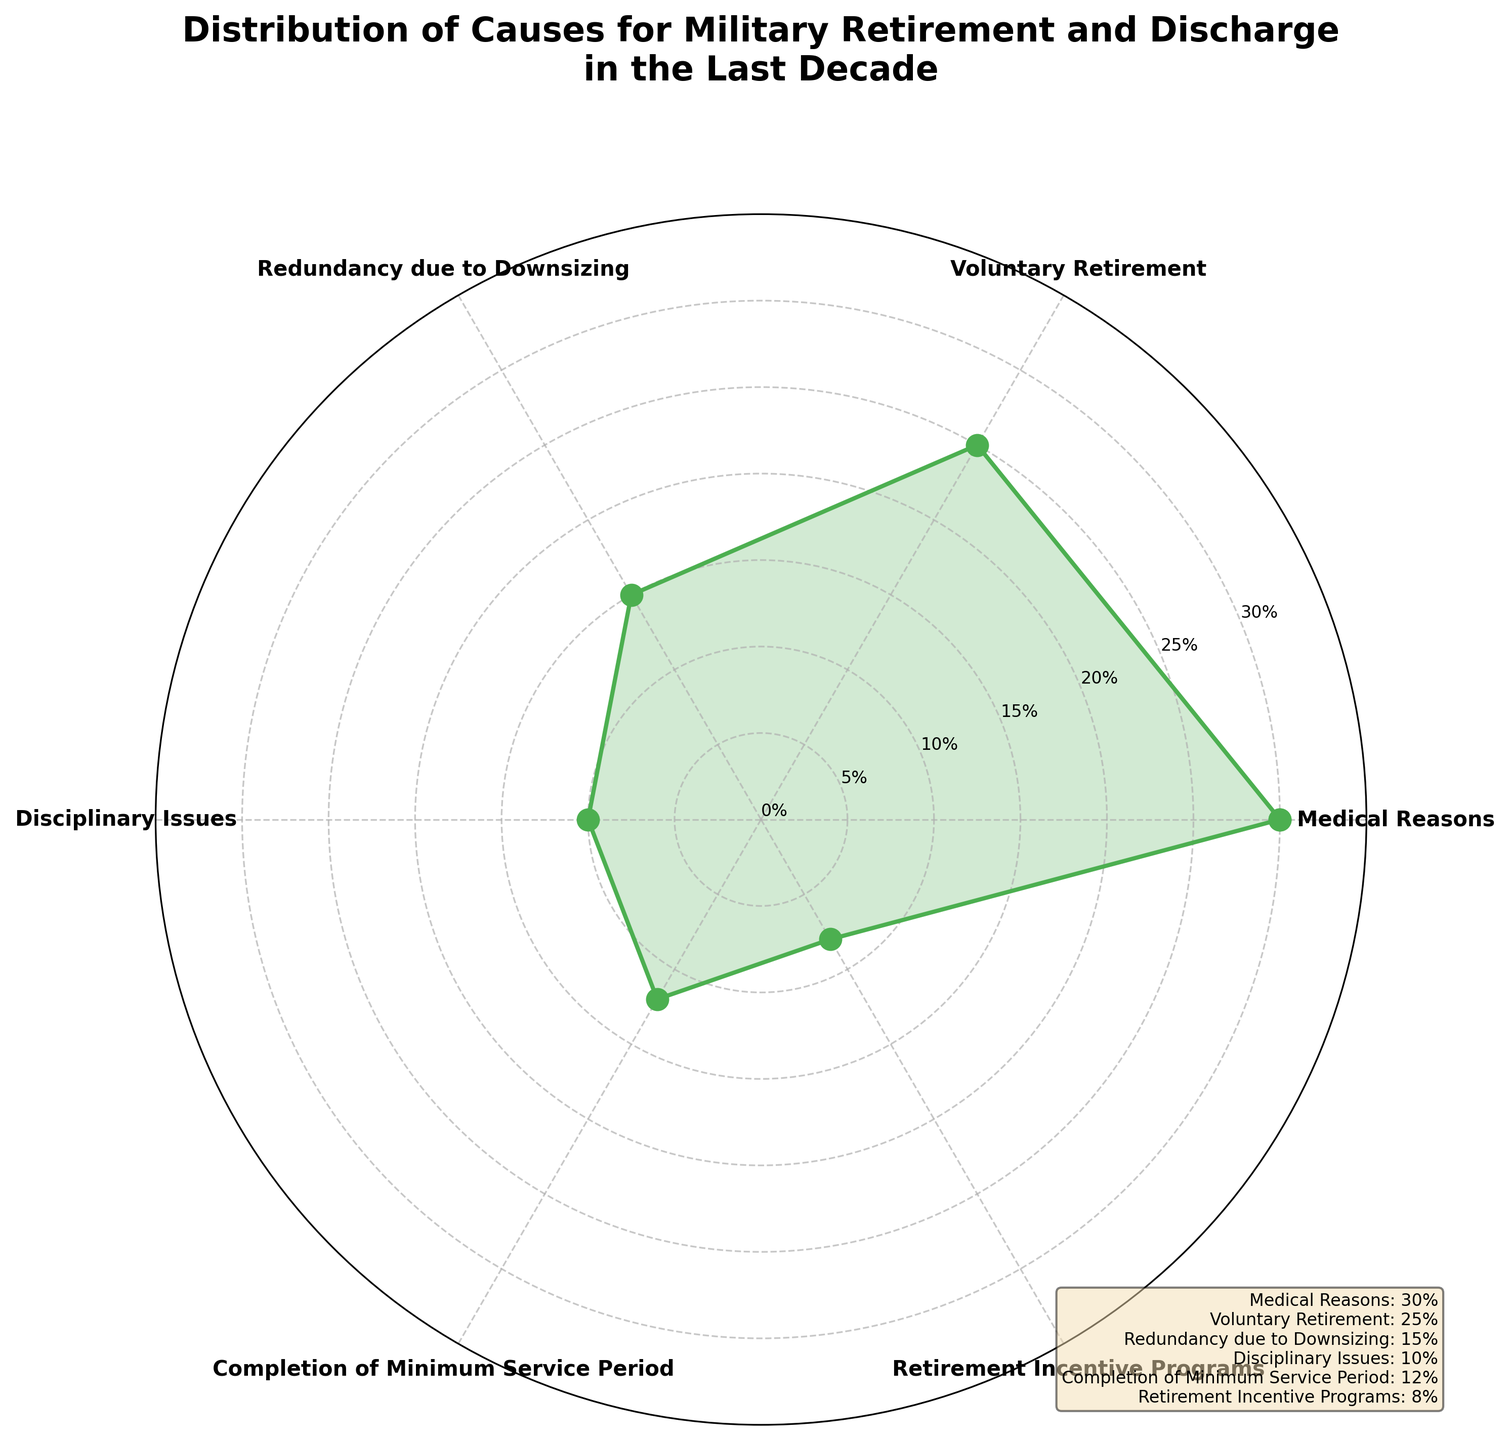what is the highest percentage cause for military retirement and discharge? The visual information in the figure indicates the causes and their respective percentages. The section labeled "Medical Reasons" has the largest area.
Answer: Medical Reasons Which cause has the smallest percentage for military retirement and discharge? The visual information in the figure shows that "Retirement Incentive Programs" has the smallest area.
Answer: Retirement Incentive Programs What is the title of the polar area chart? The title is displayed at the top of the chart. It reads "Distribution of Causes for Military Retirement and Discharge in the Last Decade."
Answer: Distribution of Causes for Military Retirement and Discharge in the Last Decade What is the combined percentage for Voluntary Retirement and Completion of Minimum Service Period? To calculate the combined percentage, refer to the chart for each percentage: Voluntary Retirement is 25%, and Completion of Minimum Service Period is 12%. Adding these values gives 25% + 12%.
Answer: 37% Which cause has a greater percentage, Disciplinary Issues or Redundancy due to Downsizing? To compare the two causes, refer to the chart: Disciplinary Issues have 10%, and Redundancy due to Downsizing has 15%. Therefore, Redundancy due to Downsizing has a higher percentage.
Answer: Redundancy due to Downsizing What are the y-axis labels on the polar chart? The y-axis labels are displayed as circular lines on the chart, starting from the center and moving outwards. They are 0%, 5%, 10%, 15%, 20%, 25%, 30%, and 35%.
Answer: 0%, 5%, 10%, 15%, 20%, 25%, 30%, 35% By how much does the percentage for Medical Reasons exceed that for Voluntary Retirement? Medical Reasons account for 30%, and Voluntary Retirement is 25%. The difference is calculated as 30% - 25%.
Answer: 5% What percentage does Redundancy due to Downsizing contribute to military retirement and discharge? The angle and area corresponding to "Redundancy due to Downsizing" in the chart shows its percentage, which is 15%.
Answer: 15% Compare the sum of percentages for Disciplinary Issues and Retirement Incentive Programs to Medical Reasons. Disciplinary Issues are 10%, and Retirement Incentive Programs are 8%. Their sum is 10% + 8% = 18%. Medical Reasons are 30%. Compare these sums: 30% vs. 18%.
Answer: Less Which cause is second most common for military retirement and discharge? The visual information shows that the second largest area is labeled "Voluntary Retirement" with a percentage of 25%.
Answer: Voluntary Retirement 